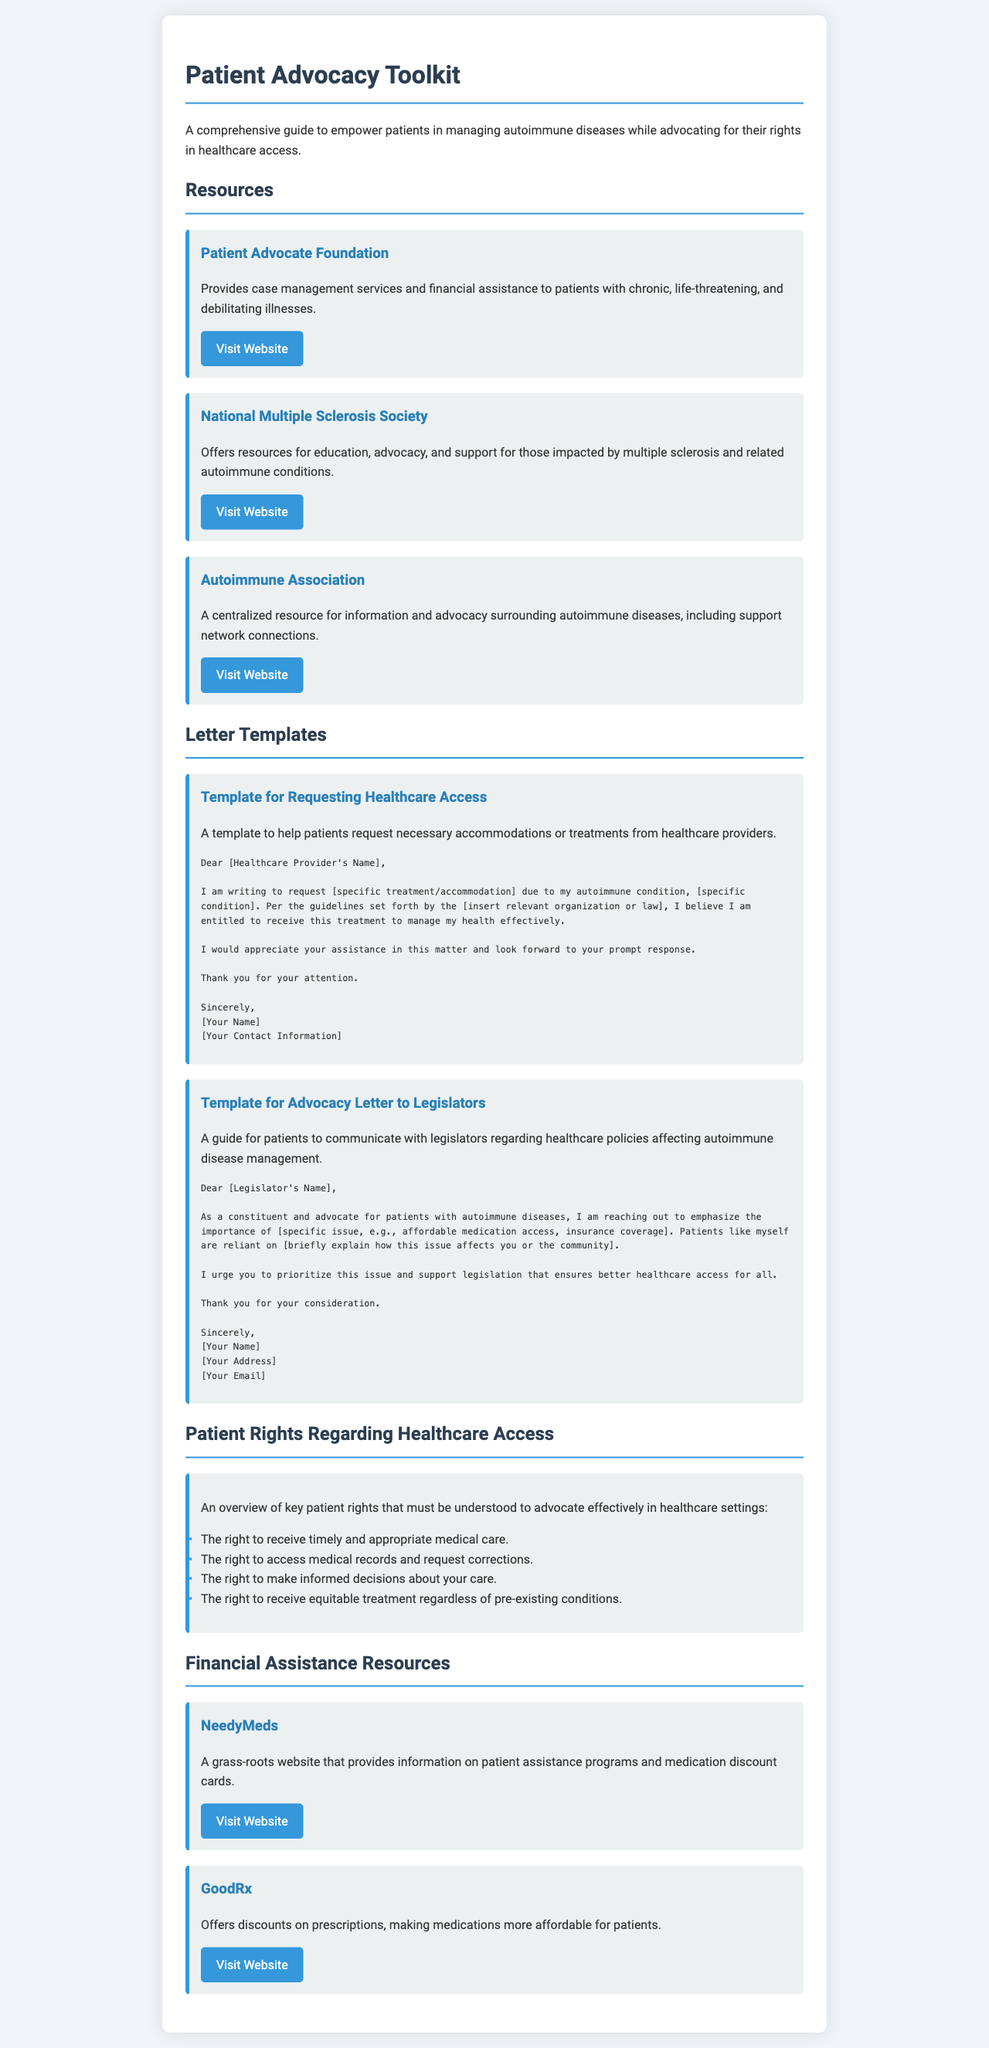What is the title of the document? The title is explicitly stated in the document header.
Answer: Patient Advocacy Toolkit How many resources are listed in the document? The document provides a specific count of resources under the "Resources" section.
Answer: 3 What is the first resource mentioned? The first resource is identified by its heading in the "Resources" section.
Answer: Patient Advocate Foundation What is the purpose of the letter templates? The document outlines the intent of the letter templates in the "Letter Templates" section.
Answer: To help patients request necessary accommodations or treatments Name one right patients have regarding healthcare access. The rights are detailed in a list, highlighting key patient rights.
Answer: The right to receive timely and appropriate medical care What is the website for the Autoimmune Association? The document provides the URL of the Autoimmune Association resource.
Answer: https://www.autoimmune.org How does GoodRx assist patients? The function of GoodRx is described in the "Financial Assistance Resources" section.
Answer: Offers discounts on prescriptions What type of information does NeedyMeds provide? The overview given in the document specifies the type of information available through NeedyMeds.
Answer: Patient assistance programs What issue should patients urge legislators to address according to the template? The template for advocacy letters mentions a specific issue for patients to address.
Answer: Affordable medication access 